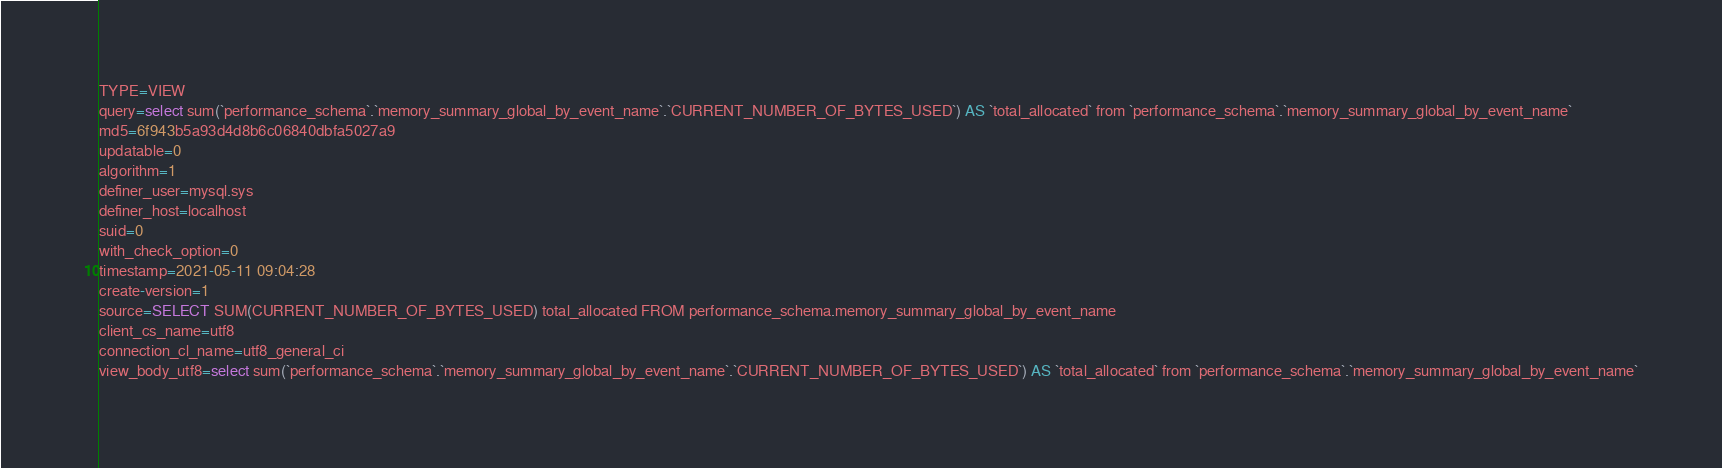Convert code to text. <code><loc_0><loc_0><loc_500><loc_500><_VisualBasic_>TYPE=VIEW
query=select sum(`performance_schema`.`memory_summary_global_by_event_name`.`CURRENT_NUMBER_OF_BYTES_USED`) AS `total_allocated` from `performance_schema`.`memory_summary_global_by_event_name`
md5=6f943b5a93d4d8b6c06840dbfa5027a9
updatable=0
algorithm=1
definer_user=mysql.sys
definer_host=localhost
suid=0
with_check_option=0
timestamp=2021-05-11 09:04:28
create-version=1
source=SELECT SUM(CURRENT_NUMBER_OF_BYTES_USED) total_allocated FROM performance_schema.memory_summary_global_by_event_name
client_cs_name=utf8
connection_cl_name=utf8_general_ci
view_body_utf8=select sum(`performance_schema`.`memory_summary_global_by_event_name`.`CURRENT_NUMBER_OF_BYTES_USED`) AS `total_allocated` from `performance_schema`.`memory_summary_global_by_event_name`
</code> 